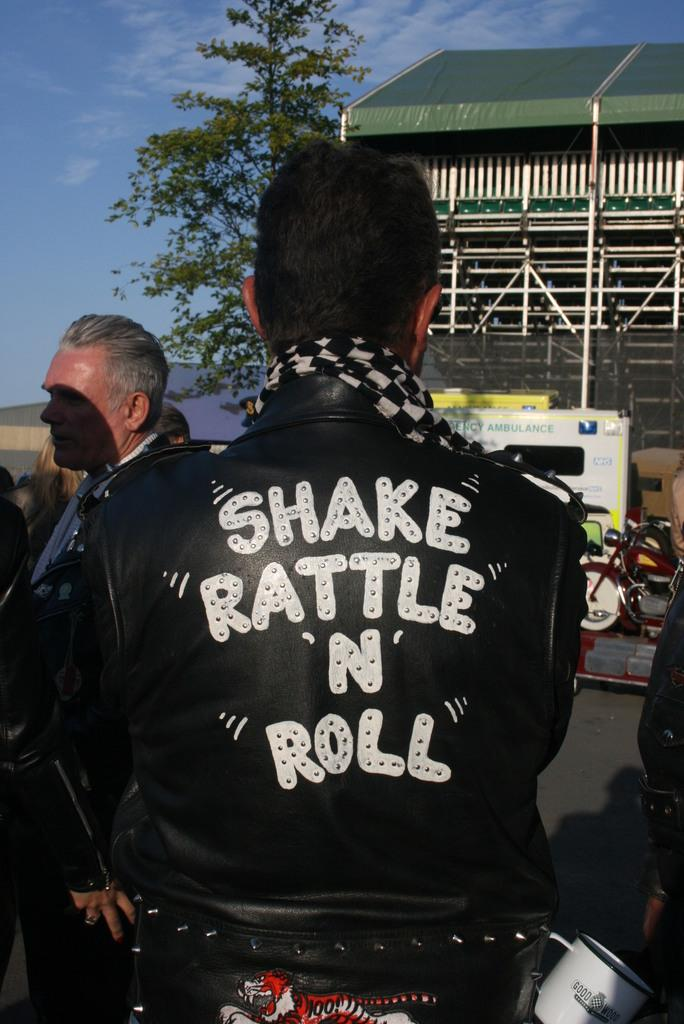Who is present in the image? There is a man in the image. What is the man wearing? The man is wearing a black jacket. What can be seen on the jacket? There is something written on the jacket. What is in front of the man? There is a house and a tree in front of the man. What is the color of the sky in the image? The sky is blue in the image. What type of metal can be seen on the hydrant near the tree in the image? There is no hydrant present in the image, and therefore no metal can be seen on it. How many lizards are climbing on the house in the image? There are no lizards present in the image, so it is impossible to determine how many might be climbing on the house. 